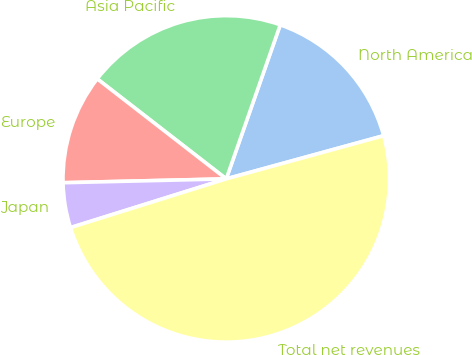<chart> <loc_0><loc_0><loc_500><loc_500><pie_chart><fcel>North America<fcel>Asia Pacific<fcel>Europe<fcel>Japan<fcel>Total net revenues<nl><fcel>15.37%<fcel>19.87%<fcel>10.87%<fcel>4.45%<fcel>49.43%<nl></chart> 